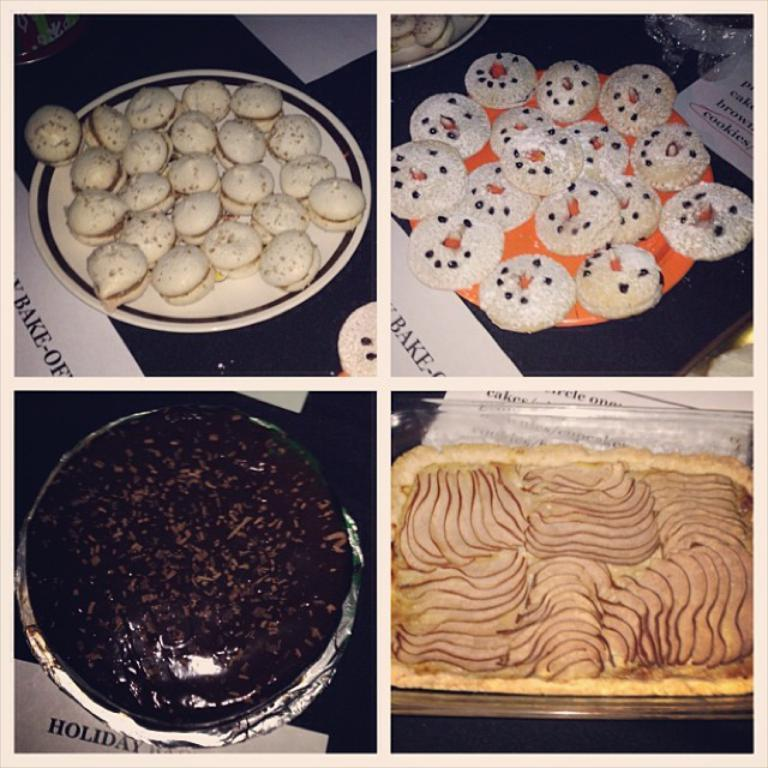How many images are in the collage? The collage contains four images. What is present on each image? Each image contains a plate with food items and papers on the platform. How are the plates positioned in the images? The plates are placed on platforms in each image. Reasoning: Let'g: Let's think step by step in order to produce the conversation. We start by identifying the main subject of the collage, which is the four images. Then, we describe the content of each image, focusing on the plates with food items and the papers on the platforms. We ensure that each question can be answered definitively with the information given. Absurd Question/Answer: What type of leaf is present in the image? There is no leaf present in the image; the collage consists of images of plates with food items and papers on platforms. What type of ghost can be seen interacting with the plates in the image? There is no ghost present in the image; the collage consists of images of plates with food items and papers on platforms. 